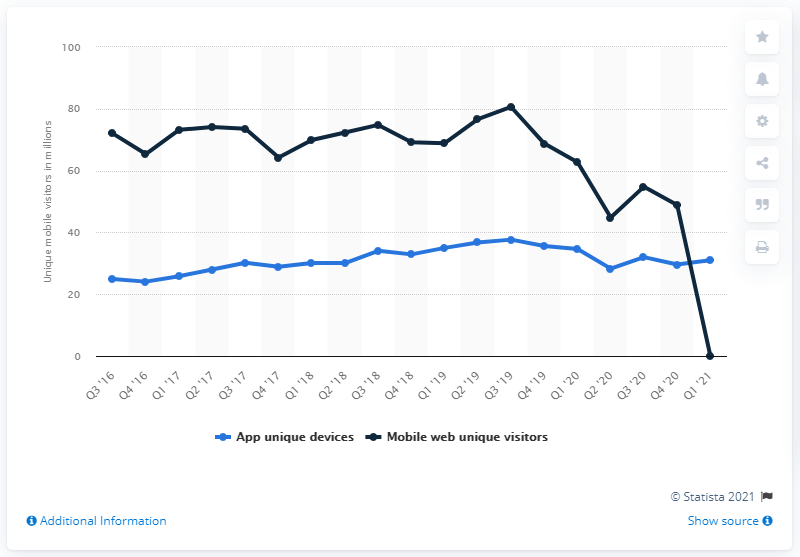Outline some significant characteristics in this image. Yelp had 31 unique mobile app devices in the first quarter of 2021. 